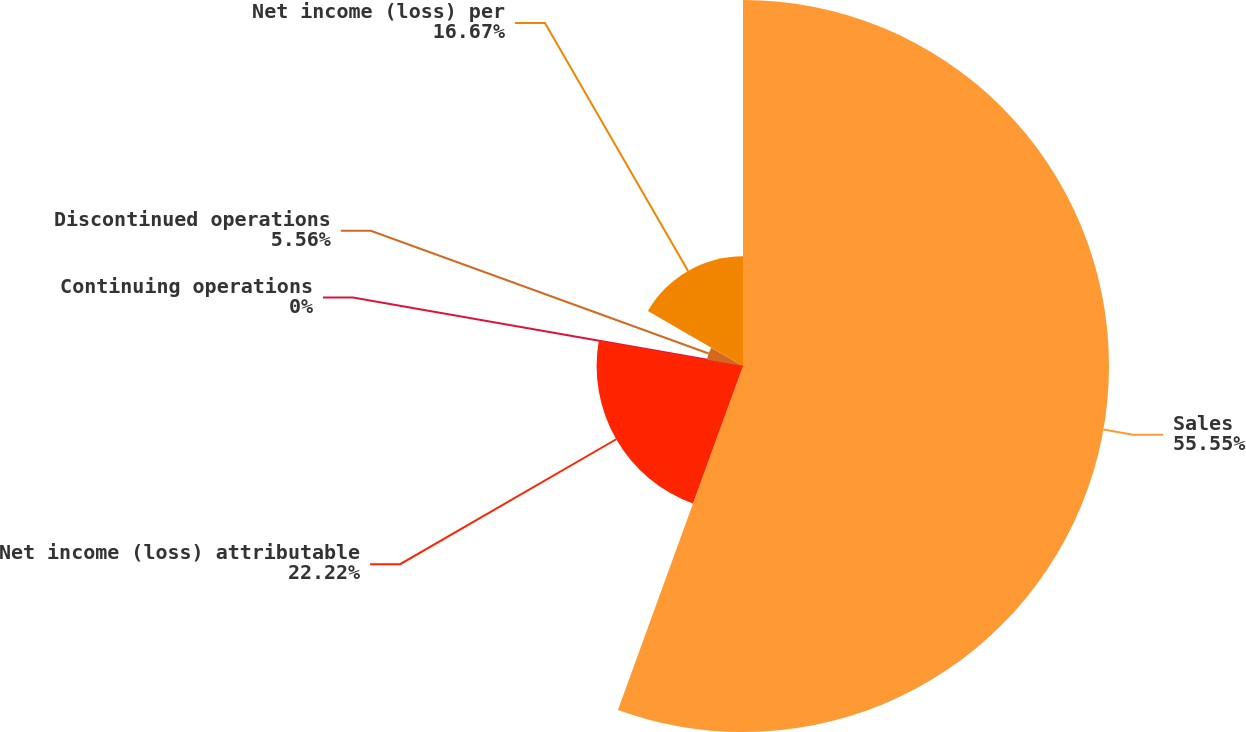Convert chart. <chart><loc_0><loc_0><loc_500><loc_500><pie_chart><fcel>Sales<fcel>Net income (loss) attributable<fcel>Continuing operations<fcel>Discontinued operations<fcel>Net income (loss) per<nl><fcel>55.55%<fcel>22.22%<fcel>0.0%<fcel>5.56%<fcel>16.67%<nl></chart> 